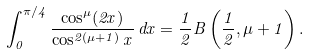Convert formula to latex. <formula><loc_0><loc_0><loc_500><loc_500>\int _ { 0 } ^ { \pi / 4 } \frac { \cos ^ { \mu } ( 2 x ) } { \cos ^ { 2 ( \mu + 1 ) } x } \, d x = \frac { 1 } { 2 } B \left ( \frac { 1 } { 2 } , \mu + 1 \right ) .</formula> 